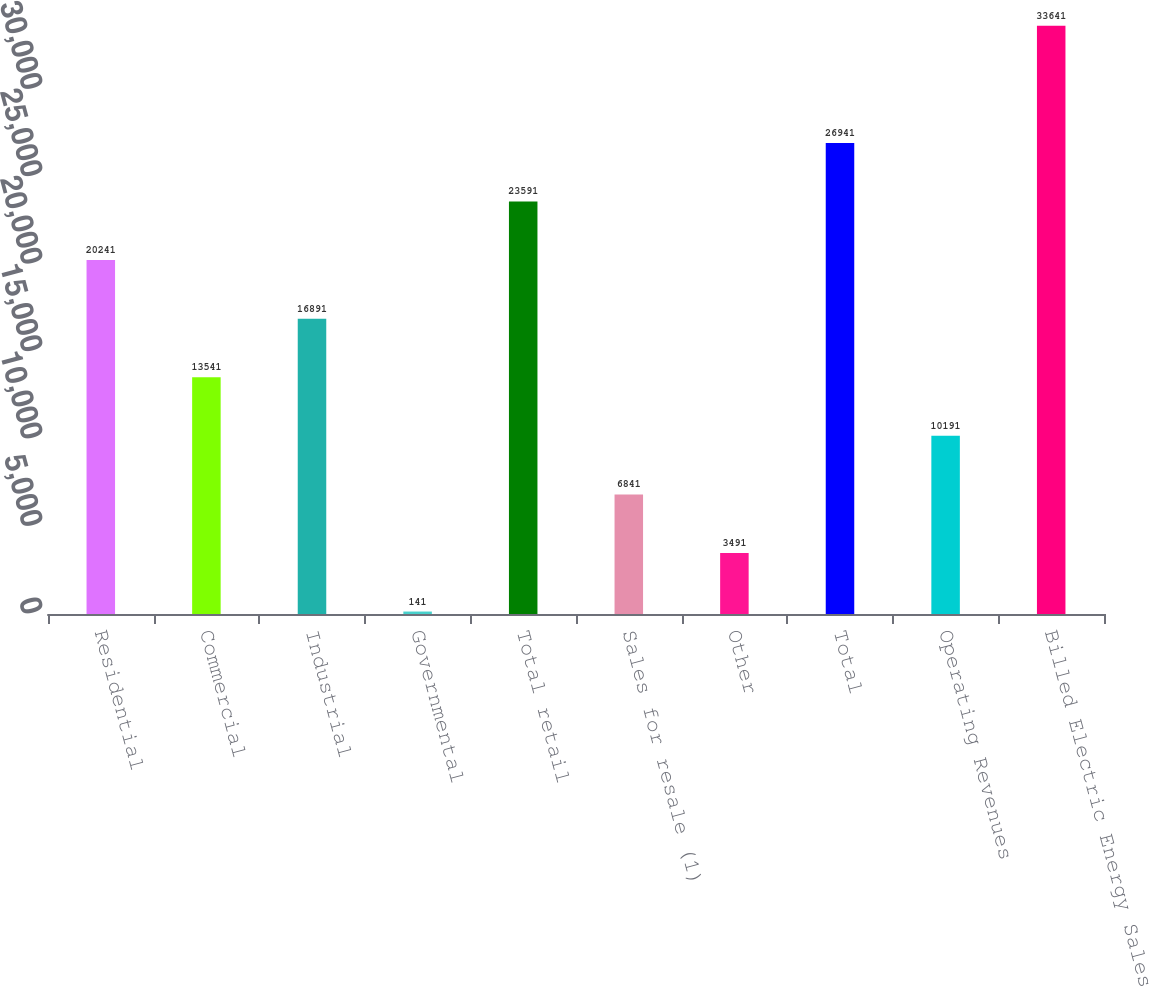Convert chart to OTSL. <chart><loc_0><loc_0><loc_500><loc_500><bar_chart><fcel>Residential<fcel>Commercial<fcel>Industrial<fcel>Governmental<fcel>Total retail<fcel>Sales for resale (1)<fcel>Other<fcel>Total<fcel>Operating Revenues<fcel>Billed Electric Energy Sales<nl><fcel>20241<fcel>13541<fcel>16891<fcel>141<fcel>23591<fcel>6841<fcel>3491<fcel>26941<fcel>10191<fcel>33641<nl></chart> 